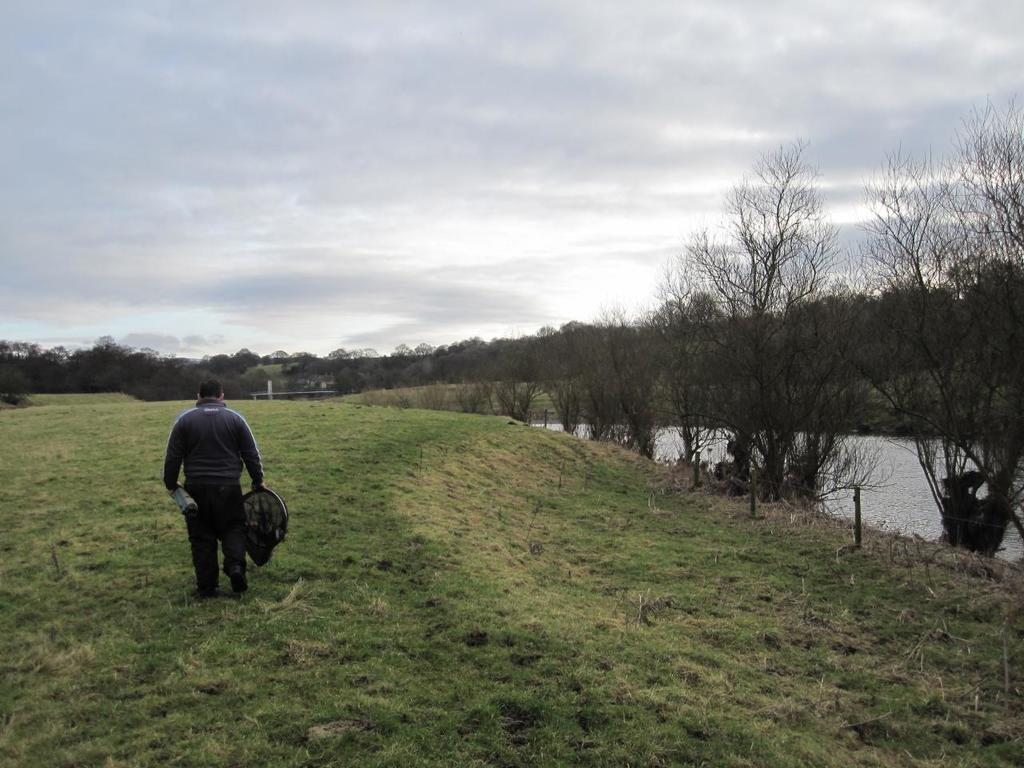What is the main subject of the image? There is a person in the image. What is the person holding in the image? The person is holding something. Where is the person standing in the image? The person is standing on grass. What can be seen on the right side of the image? There are trees and water on the right side of the image. What is visible in the background of the image? There are trees and the sky visible in the background of the image. What color are the ants crawling on the person's hand in the image? There are no ants present in the image, so we cannot determine their color. 